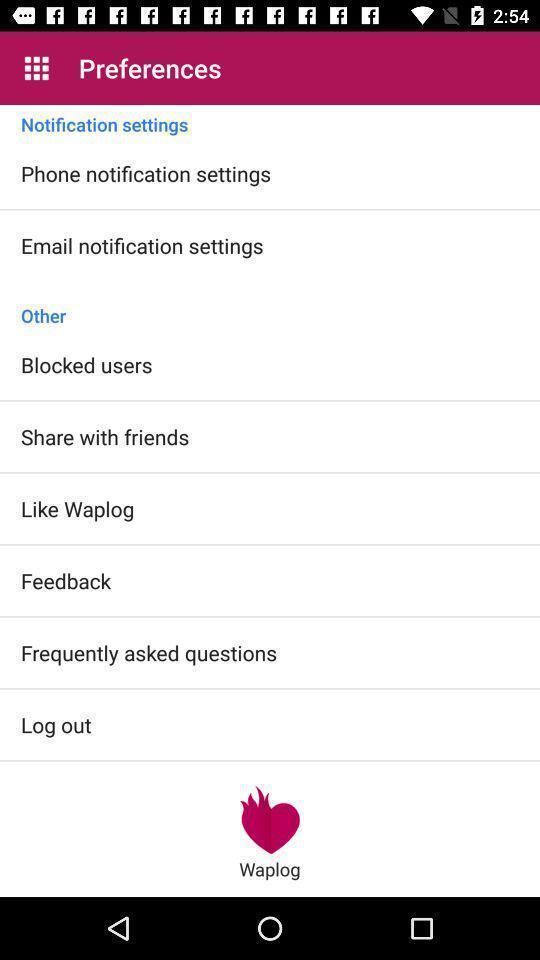Tell me about the visual elements in this screen capture. Page displaying list of options for preferences. 